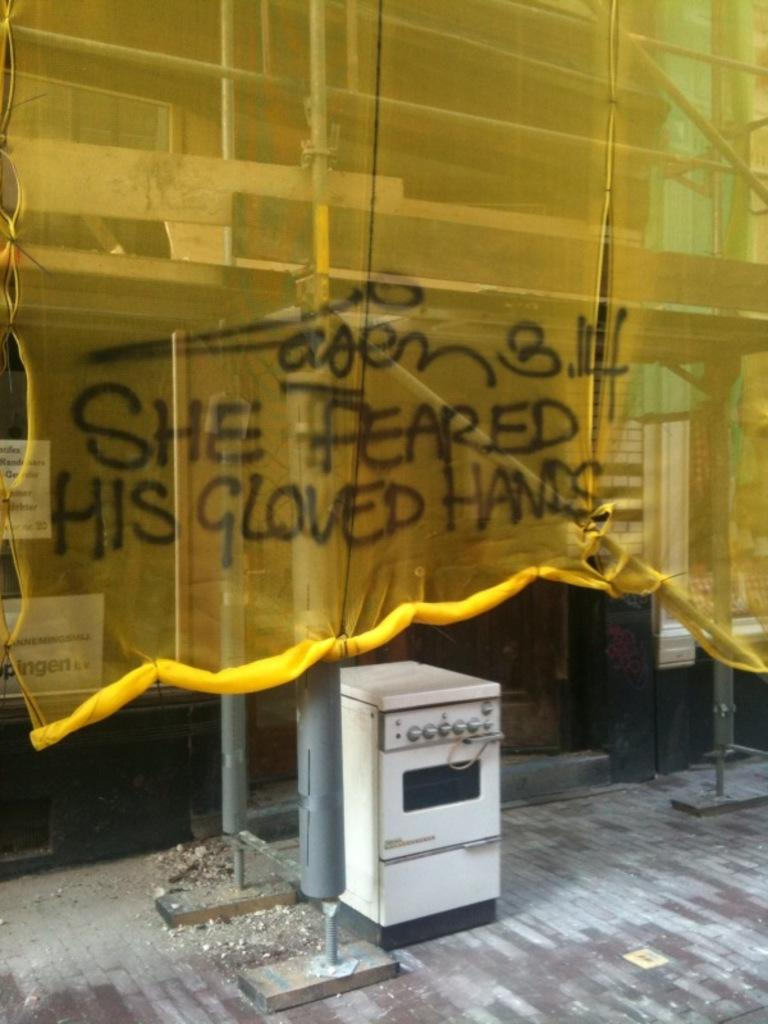<image>
Relay a brief, clear account of the picture shown. A construction site that has a yellow see through tarp over it that has graffiti that says She feared his gloved hand on it 